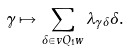Convert formula to latex. <formula><loc_0><loc_0><loc_500><loc_500>\gamma \mapsto \sum _ { \delta \in v Q _ { 1 } w } { \lambda _ { \gamma \delta } { \delta } } .</formula> 